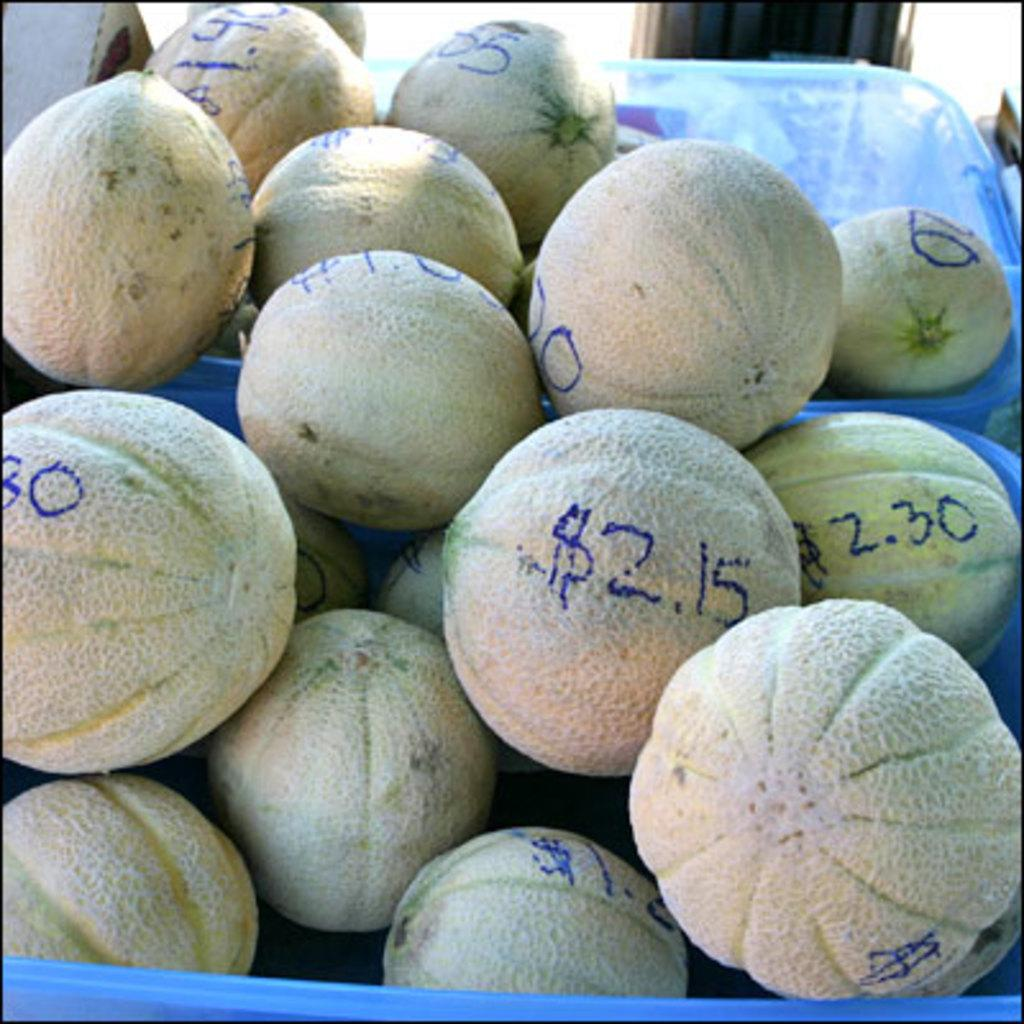What type of fruit is present in the image? There are muskmelons in the image. How are the muskmelons arranged or stored in the image? The muskmelons are in baskets. What type of cloud can be seen in the image? There are no clouds present in the image; it features muskmelons in baskets. What color is the underwear worn by the muskmelons in the image? Muskmelons do not wear underwear, as they are fruits and not living beings. 